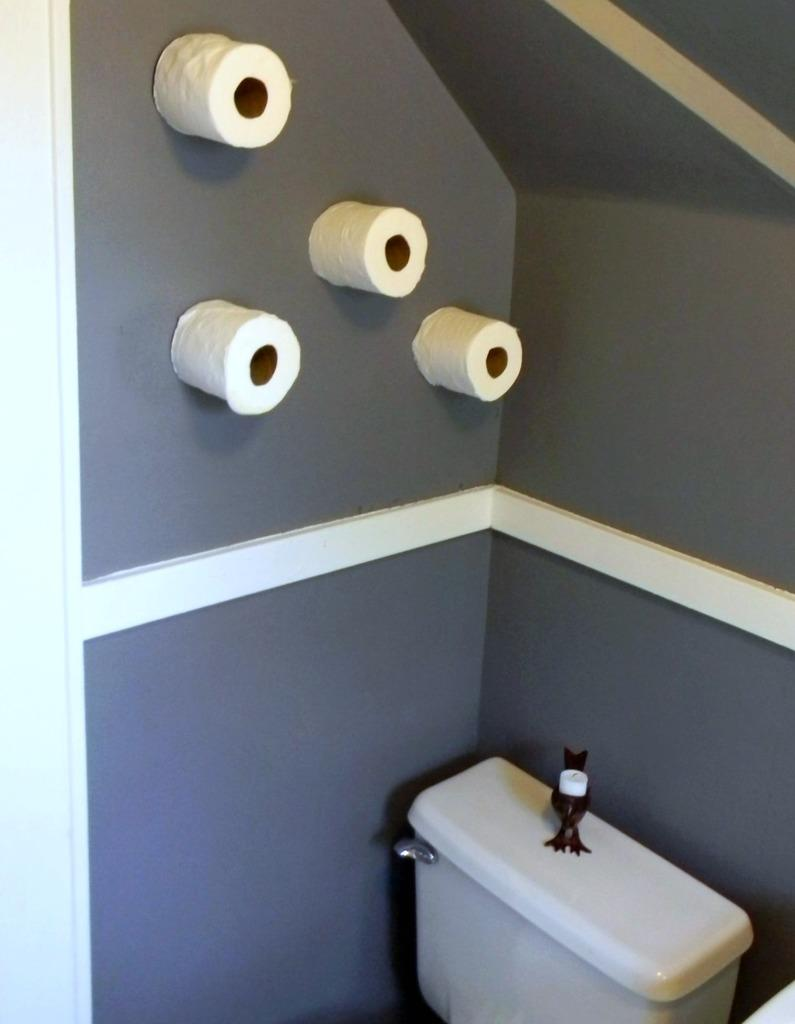What is located at the bottom of the image? There is a flush at the bottom of the image. What can be seen on the wall in the image? There are tissue rolls on the wall in the image. How is the yard being transported in the image? There is no yard present in the image, so it cannot be transported. What is the temperature of the hot item in the image? There is no hot item present in the image, so its temperature cannot be determined. 